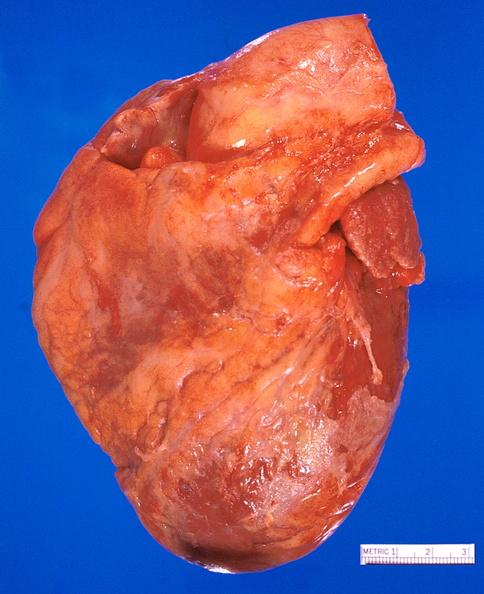what does this image show?
Answer the question using a single word or phrase. Heart 